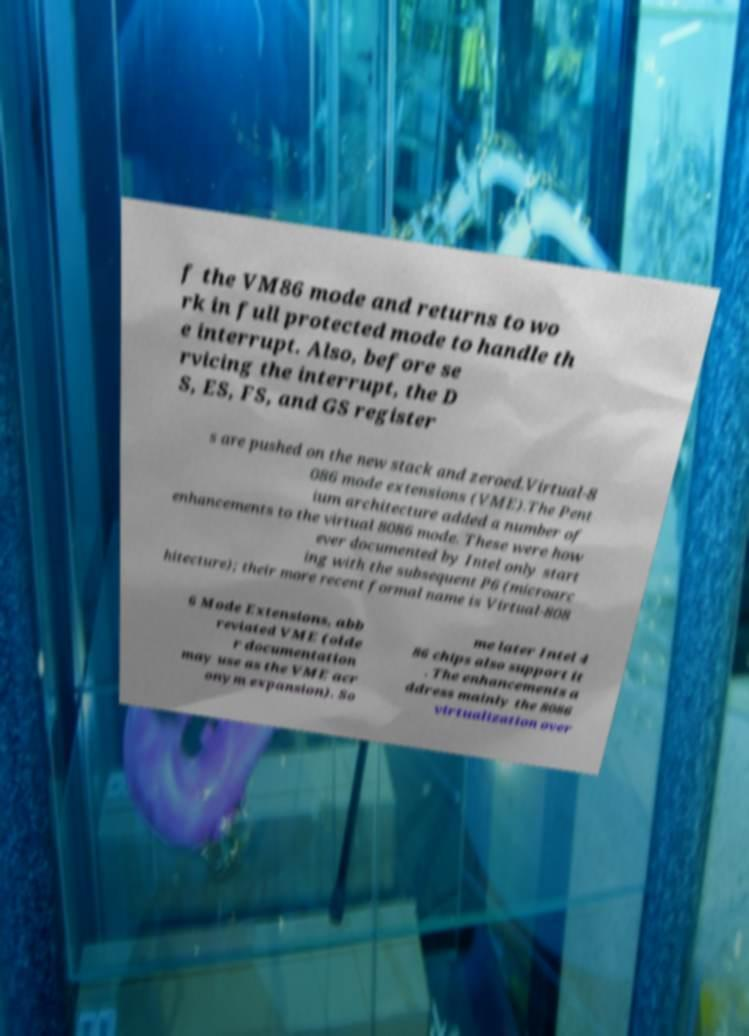Please read and relay the text visible in this image. What does it say? f the VM86 mode and returns to wo rk in full protected mode to handle th e interrupt. Also, before se rvicing the interrupt, the D S, ES, FS, and GS register s are pushed on the new stack and zeroed.Virtual-8 086 mode extensions (VME).The Pent ium architecture added a number of enhancements to the virtual 8086 mode. These were how ever documented by Intel only start ing with the subsequent P6 (microarc hitecture); their more recent formal name is Virtual-808 6 Mode Extensions, abb reviated VME (olde r documentation may use as the VME acr onym expansion). So me later Intel 4 86 chips also support it . The enhancements a ddress mainly the 8086 virtualization over 